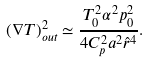Convert formula to latex. <formula><loc_0><loc_0><loc_500><loc_500>( \nabla T ) ^ { 2 } _ { o u t } \simeq \frac { T _ { 0 } ^ { 2 } \alpha ^ { 2 } p _ { 0 } ^ { 2 } } { 4 C _ { p } ^ { 2 } a ^ { 2 } \hat { r } ^ { 4 } } .</formula> 